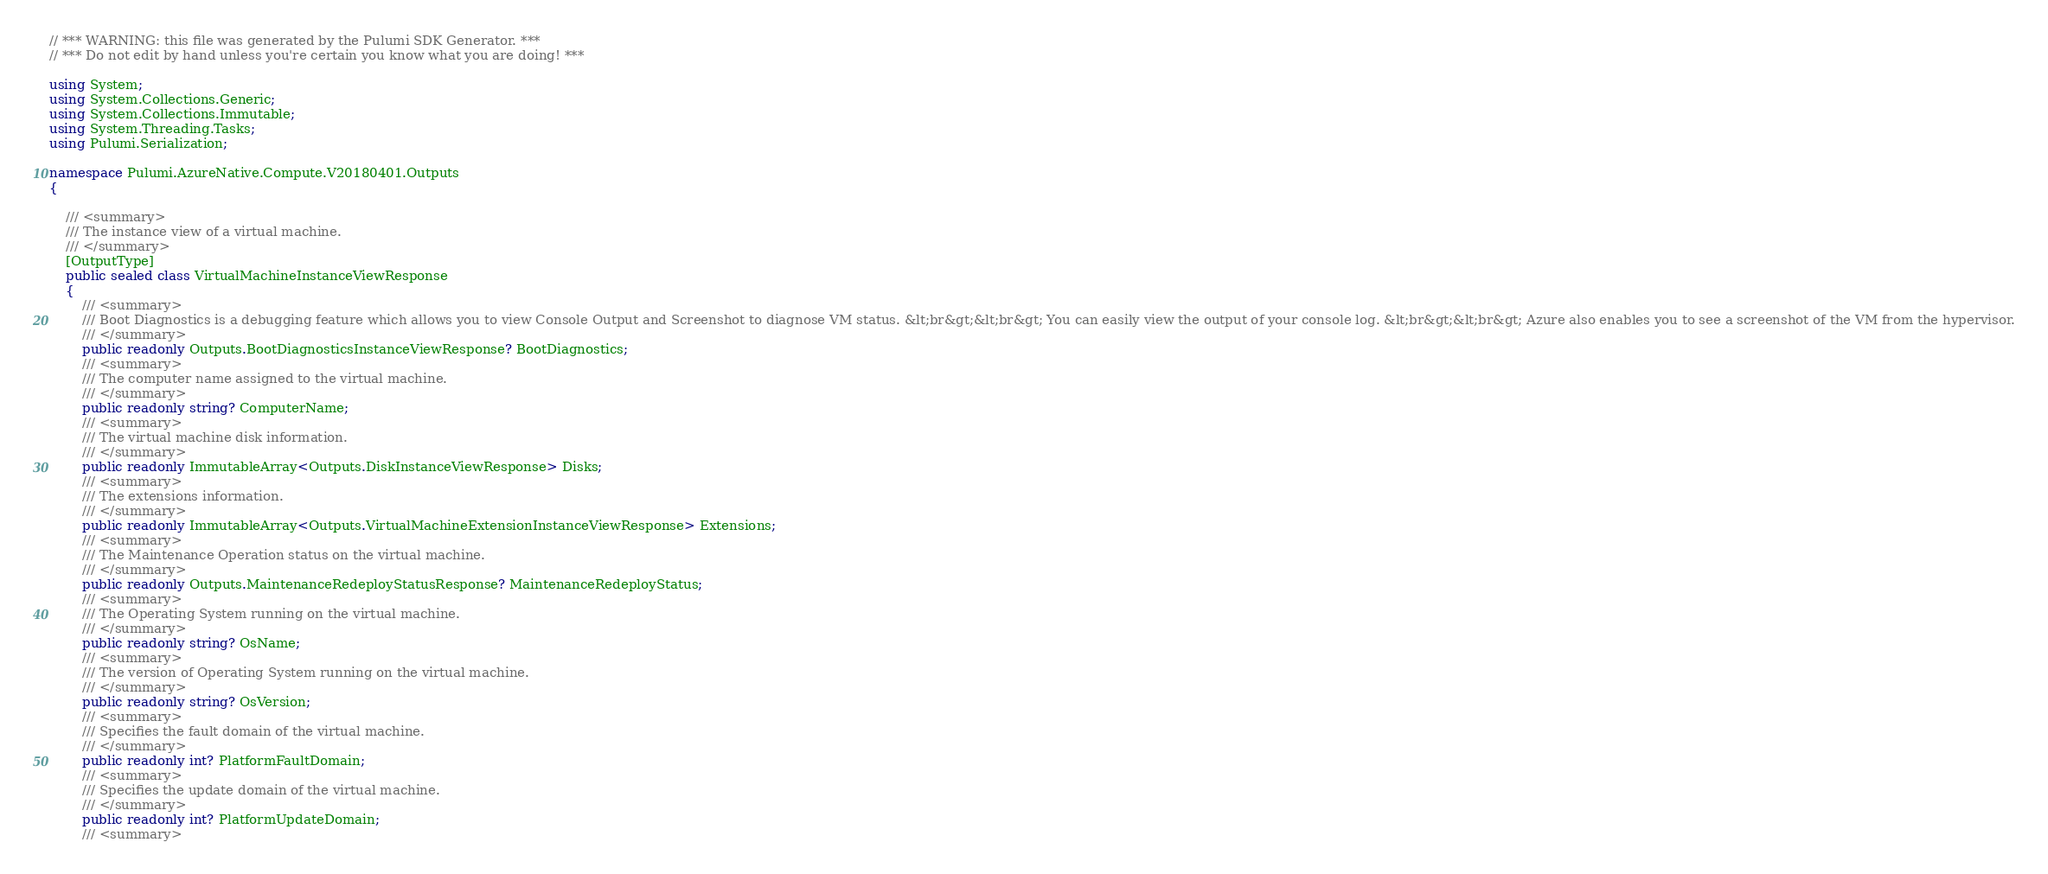Convert code to text. <code><loc_0><loc_0><loc_500><loc_500><_C#_>// *** WARNING: this file was generated by the Pulumi SDK Generator. ***
// *** Do not edit by hand unless you're certain you know what you are doing! ***

using System;
using System.Collections.Generic;
using System.Collections.Immutable;
using System.Threading.Tasks;
using Pulumi.Serialization;

namespace Pulumi.AzureNative.Compute.V20180401.Outputs
{

    /// <summary>
    /// The instance view of a virtual machine.
    /// </summary>
    [OutputType]
    public sealed class VirtualMachineInstanceViewResponse
    {
        /// <summary>
        /// Boot Diagnostics is a debugging feature which allows you to view Console Output and Screenshot to diagnose VM status. &lt;br&gt;&lt;br&gt; You can easily view the output of your console log. &lt;br&gt;&lt;br&gt; Azure also enables you to see a screenshot of the VM from the hypervisor.
        /// </summary>
        public readonly Outputs.BootDiagnosticsInstanceViewResponse? BootDiagnostics;
        /// <summary>
        /// The computer name assigned to the virtual machine.
        /// </summary>
        public readonly string? ComputerName;
        /// <summary>
        /// The virtual machine disk information.
        /// </summary>
        public readonly ImmutableArray<Outputs.DiskInstanceViewResponse> Disks;
        /// <summary>
        /// The extensions information.
        /// </summary>
        public readonly ImmutableArray<Outputs.VirtualMachineExtensionInstanceViewResponse> Extensions;
        /// <summary>
        /// The Maintenance Operation status on the virtual machine.
        /// </summary>
        public readonly Outputs.MaintenanceRedeployStatusResponse? MaintenanceRedeployStatus;
        /// <summary>
        /// The Operating System running on the virtual machine.
        /// </summary>
        public readonly string? OsName;
        /// <summary>
        /// The version of Operating System running on the virtual machine.
        /// </summary>
        public readonly string? OsVersion;
        /// <summary>
        /// Specifies the fault domain of the virtual machine.
        /// </summary>
        public readonly int? PlatformFaultDomain;
        /// <summary>
        /// Specifies the update domain of the virtual machine.
        /// </summary>
        public readonly int? PlatformUpdateDomain;
        /// <summary></code> 